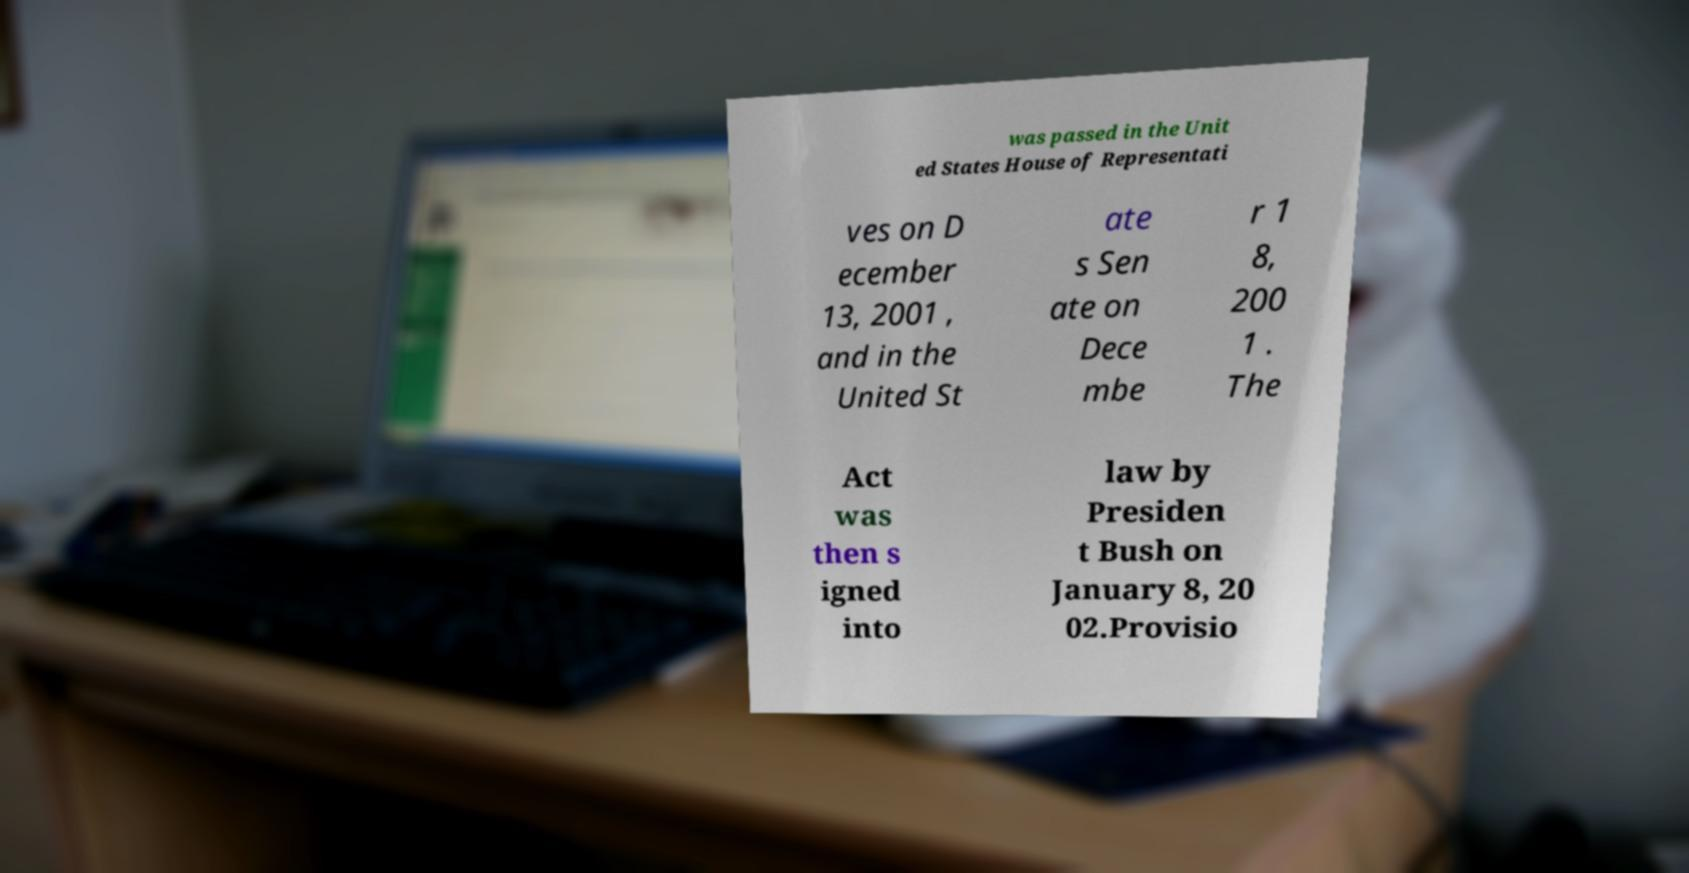There's text embedded in this image that I need extracted. Can you transcribe it verbatim? was passed in the Unit ed States House of Representati ves on D ecember 13, 2001 , and in the United St ate s Sen ate on Dece mbe r 1 8, 200 1 . The Act was then s igned into law by Presiden t Bush on January 8, 20 02.Provisio 